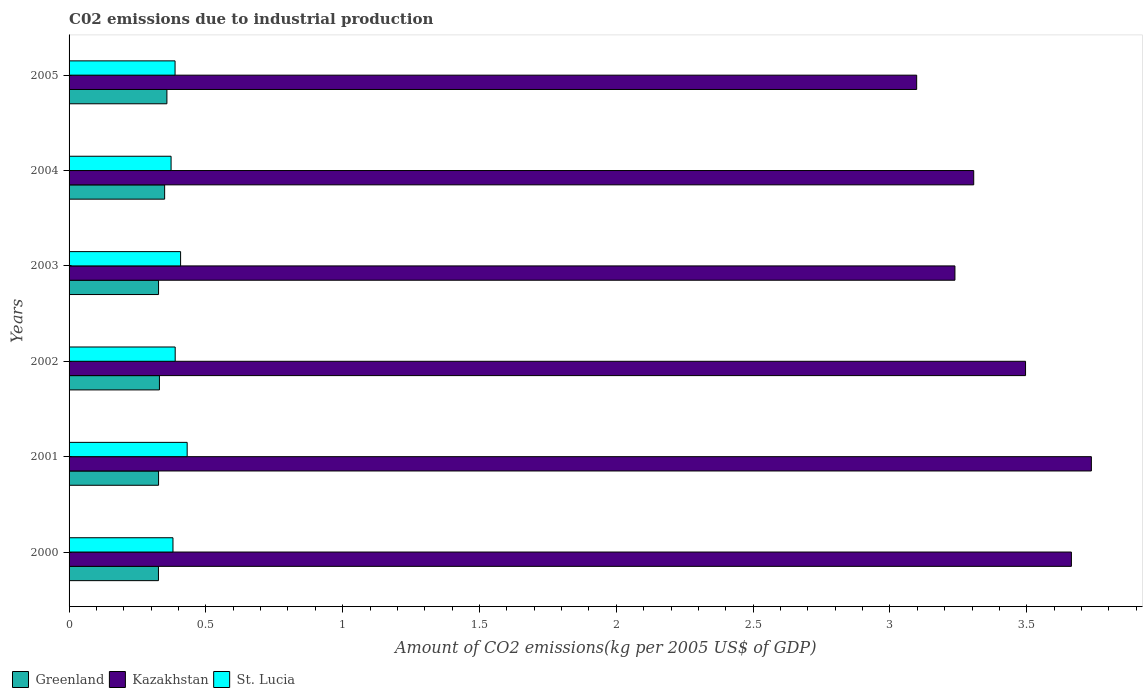Are the number of bars per tick equal to the number of legend labels?
Keep it short and to the point. Yes. Are the number of bars on each tick of the Y-axis equal?
Keep it short and to the point. Yes. How many bars are there on the 2nd tick from the top?
Your answer should be very brief. 3. How many bars are there on the 1st tick from the bottom?
Your response must be concise. 3. In how many cases, is the number of bars for a given year not equal to the number of legend labels?
Give a very brief answer. 0. What is the amount of CO2 emitted due to industrial production in Greenland in 2004?
Give a very brief answer. 0.35. Across all years, what is the maximum amount of CO2 emitted due to industrial production in St. Lucia?
Ensure brevity in your answer.  0.43. Across all years, what is the minimum amount of CO2 emitted due to industrial production in Greenland?
Your answer should be compact. 0.33. In which year was the amount of CO2 emitted due to industrial production in Greenland maximum?
Your answer should be compact. 2005. What is the total amount of CO2 emitted due to industrial production in St. Lucia in the graph?
Keep it short and to the point. 2.37. What is the difference between the amount of CO2 emitted due to industrial production in Greenland in 2003 and that in 2004?
Provide a succinct answer. -0.02. What is the difference between the amount of CO2 emitted due to industrial production in St. Lucia in 2004 and the amount of CO2 emitted due to industrial production in Kazakhstan in 2000?
Ensure brevity in your answer.  -3.29. What is the average amount of CO2 emitted due to industrial production in St. Lucia per year?
Keep it short and to the point. 0.39. In the year 2000, what is the difference between the amount of CO2 emitted due to industrial production in St. Lucia and amount of CO2 emitted due to industrial production in Greenland?
Your response must be concise. 0.05. What is the ratio of the amount of CO2 emitted due to industrial production in St. Lucia in 2001 to that in 2002?
Ensure brevity in your answer.  1.11. Is the amount of CO2 emitted due to industrial production in Kazakhstan in 2000 less than that in 2002?
Offer a terse response. No. Is the difference between the amount of CO2 emitted due to industrial production in St. Lucia in 2003 and 2005 greater than the difference between the amount of CO2 emitted due to industrial production in Greenland in 2003 and 2005?
Keep it short and to the point. Yes. What is the difference between the highest and the second highest amount of CO2 emitted due to industrial production in Kazakhstan?
Offer a very short reply. 0.07. What is the difference between the highest and the lowest amount of CO2 emitted due to industrial production in Greenland?
Your answer should be very brief. 0.03. What does the 3rd bar from the top in 2003 represents?
Your answer should be compact. Greenland. What does the 3rd bar from the bottom in 2003 represents?
Your response must be concise. St. Lucia. Is it the case that in every year, the sum of the amount of CO2 emitted due to industrial production in St. Lucia and amount of CO2 emitted due to industrial production in Greenland is greater than the amount of CO2 emitted due to industrial production in Kazakhstan?
Ensure brevity in your answer.  No. How many bars are there?
Provide a succinct answer. 18. Are all the bars in the graph horizontal?
Your answer should be compact. Yes. Are the values on the major ticks of X-axis written in scientific E-notation?
Make the answer very short. No. Where does the legend appear in the graph?
Offer a very short reply. Bottom left. What is the title of the graph?
Ensure brevity in your answer.  C02 emissions due to industrial production. Does "Swaziland" appear as one of the legend labels in the graph?
Provide a short and direct response. No. What is the label or title of the X-axis?
Your response must be concise. Amount of CO2 emissions(kg per 2005 US$ of GDP). What is the label or title of the Y-axis?
Provide a succinct answer. Years. What is the Amount of CO2 emissions(kg per 2005 US$ of GDP) of Greenland in 2000?
Your response must be concise. 0.33. What is the Amount of CO2 emissions(kg per 2005 US$ of GDP) in Kazakhstan in 2000?
Your answer should be very brief. 3.66. What is the Amount of CO2 emissions(kg per 2005 US$ of GDP) in St. Lucia in 2000?
Offer a very short reply. 0.38. What is the Amount of CO2 emissions(kg per 2005 US$ of GDP) of Greenland in 2001?
Offer a very short reply. 0.33. What is the Amount of CO2 emissions(kg per 2005 US$ of GDP) in Kazakhstan in 2001?
Your response must be concise. 3.74. What is the Amount of CO2 emissions(kg per 2005 US$ of GDP) of St. Lucia in 2001?
Your answer should be very brief. 0.43. What is the Amount of CO2 emissions(kg per 2005 US$ of GDP) of Greenland in 2002?
Give a very brief answer. 0.33. What is the Amount of CO2 emissions(kg per 2005 US$ of GDP) of Kazakhstan in 2002?
Ensure brevity in your answer.  3.5. What is the Amount of CO2 emissions(kg per 2005 US$ of GDP) of St. Lucia in 2002?
Your response must be concise. 0.39. What is the Amount of CO2 emissions(kg per 2005 US$ of GDP) of Greenland in 2003?
Keep it short and to the point. 0.33. What is the Amount of CO2 emissions(kg per 2005 US$ of GDP) of Kazakhstan in 2003?
Provide a succinct answer. 3.24. What is the Amount of CO2 emissions(kg per 2005 US$ of GDP) of St. Lucia in 2003?
Keep it short and to the point. 0.41. What is the Amount of CO2 emissions(kg per 2005 US$ of GDP) in Greenland in 2004?
Provide a short and direct response. 0.35. What is the Amount of CO2 emissions(kg per 2005 US$ of GDP) of Kazakhstan in 2004?
Make the answer very short. 3.31. What is the Amount of CO2 emissions(kg per 2005 US$ of GDP) in St. Lucia in 2004?
Provide a succinct answer. 0.37. What is the Amount of CO2 emissions(kg per 2005 US$ of GDP) in Greenland in 2005?
Keep it short and to the point. 0.36. What is the Amount of CO2 emissions(kg per 2005 US$ of GDP) in Kazakhstan in 2005?
Provide a short and direct response. 3.1. What is the Amount of CO2 emissions(kg per 2005 US$ of GDP) of St. Lucia in 2005?
Your response must be concise. 0.39. Across all years, what is the maximum Amount of CO2 emissions(kg per 2005 US$ of GDP) in Greenland?
Your answer should be compact. 0.36. Across all years, what is the maximum Amount of CO2 emissions(kg per 2005 US$ of GDP) in Kazakhstan?
Offer a very short reply. 3.74. Across all years, what is the maximum Amount of CO2 emissions(kg per 2005 US$ of GDP) in St. Lucia?
Provide a short and direct response. 0.43. Across all years, what is the minimum Amount of CO2 emissions(kg per 2005 US$ of GDP) in Greenland?
Keep it short and to the point. 0.33. Across all years, what is the minimum Amount of CO2 emissions(kg per 2005 US$ of GDP) of Kazakhstan?
Your answer should be compact. 3.1. Across all years, what is the minimum Amount of CO2 emissions(kg per 2005 US$ of GDP) of St. Lucia?
Ensure brevity in your answer.  0.37. What is the total Amount of CO2 emissions(kg per 2005 US$ of GDP) of Greenland in the graph?
Provide a succinct answer. 2.02. What is the total Amount of CO2 emissions(kg per 2005 US$ of GDP) of Kazakhstan in the graph?
Ensure brevity in your answer.  20.54. What is the total Amount of CO2 emissions(kg per 2005 US$ of GDP) in St. Lucia in the graph?
Your response must be concise. 2.37. What is the difference between the Amount of CO2 emissions(kg per 2005 US$ of GDP) in Greenland in 2000 and that in 2001?
Make the answer very short. -0. What is the difference between the Amount of CO2 emissions(kg per 2005 US$ of GDP) of Kazakhstan in 2000 and that in 2001?
Keep it short and to the point. -0.07. What is the difference between the Amount of CO2 emissions(kg per 2005 US$ of GDP) in St. Lucia in 2000 and that in 2001?
Ensure brevity in your answer.  -0.05. What is the difference between the Amount of CO2 emissions(kg per 2005 US$ of GDP) of Greenland in 2000 and that in 2002?
Your answer should be compact. -0. What is the difference between the Amount of CO2 emissions(kg per 2005 US$ of GDP) in Kazakhstan in 2000 and that in 2002?
Provide a succinct answer. 0.17. What is the difference between the Amount of CO2 emissions(kg per 2005 US$ of GDP) of St. Lucia in 2000 and that in 2002?
Give a very brief answer. -0.01. What is the difference between the Amount of CO2 emissions(kg per 2005 US$ of GDP) of Greenland in 2000 and that in 2003?
Offer a terse response. -0. What is the difference between the Amount of CO2 emissions(kg per 2005 US$ of GDP) in Kazakhstan in 2000 and that in 2003?
Give a very brief answer. 0.43. What is the difference between the Amount of CO2 emissions(kg per 2005 US$ of GDP) in St. Lucia in 2000 and that in 2003?
Your answer should be very brief. -0.03. What is the difference between the Amount of CO2 emissions(kg per 2005 US$ of GDP) in Greenland in 2000 and that in 2004?
Make the answer very short. -0.02. What is the difference between the Amount of CO2 emissions(kg per 2005 US$ of GDP) of Kazakhstan in 2000 and that in 2004?
Ensure brevity in your answer.  0.36. What is the difference between the Amount of CO2 emissions(kg per 2005 US$ of GDP) in St. Lucia in 2000 and that in 2004?
Offer a very short reply. 0.01. What is the difference between the Amount of CO2 emissions(kg per 2005 US$ of GDP) of Greenland in 2000 and that in 2005?
Your answer should be very brief. -0.03. What is the difference between the Amount of CO2 emissions(kg per 2005 US$ of GDP) of Kazakhstan in 2000 and that in 2005?
Offer a terse response. 0.57. What is the difference between the Amount of CO2 emissions(kg per 2005 US$ of GDP) in St. Lucia in 2000 and that in 2005?
Your response must be concise. -0.01. What is the difference between the Amount of CO2 emissions(kg per 2005 US$ of GDP) of Greenland in 2001 and that in 2002?
Your answer should be compact. -0. What is the difference between the Amount of CO2 emissions(kg per 2005 US$ of GDP) of Kazakhstan in 2001 and that in 2002?
Give a very brief answer. 0.24. What is the difference between the Amount of CO2 emissions(kg per 2005 US$ of GDP) of St. Lucia in 2001 and that in 2002?
Ensure brevity in your answer.  0.04. What is the difference between the Amount of CO2 emissions(kg per 2005 US$ of GDP) of Greenland in 2001 and that in 2003?
Provide a short and direct response. 0. What is the difference between the Amount of CO2 emissions(kg per 2005 US$ of GDP) in Kazakhstan in 2001 and that in 2003?
Offer a terse response. 0.5. What is the difference between the Amount of CO2 emissions(kg per 2005 US$ of GDP) in St. Lucia in 2001 and that in 2003?
Your response must be concise. 0.02. What is the difference between the Amount of CO2 emissions(kg per 2005 US$ of GDP) of Greenland in 2001 and that in 2004?
Your answer should be compact. -0.02. What is the difference between the Amount of CO2 emissions(kg per 2005 US$ of GDP) of Kazakhstan in 2001 and that in 2004?
Ensure brevity in your answer.  0.43. What is the difference between the Amount of CO2 emissions(kg per 2005 US$ of GDP) in St. Lucia in 2001 and that in 2004?
Provide a succinct answer. 0.06. What is the difference between the Amount of CO2 emissions(kg per 2005 US$ of GDP) of Greenland in 2001 and that in 2005?
Give a very brief answer. -0.03. What is the difference between the Amount of CO2 emissions(kg per 2005 US$ of GDP) in Kazakhstan in 2001 and that in 2005?
Your answer should be very brief. 0.64. What is the difference between the Amount of CO2 emissions(kg per 2005 US$ of GDP) of St. Lucia in 2001 and that in 2005?
Provide a succinct answer. 0.04. What is the difference between the Amount of CO2 emissions(kg per 2005 US$ of GDP) of Greenland in 2002 and that in 2003?
Keep it short and to the point. 0. What is the difference between the Amount of CO2 emissions(kg per 2005 US$ of GDP) in Kazakhstan in 2002 and that in 2003?
Offer a terse response. 0.26. What is the difference between the Amount of CO2 emissions(kg per 2005 US$ of GDP) in St. Lucia in 2002 and that in 2003?
Offer a terse response. -0.02. What is the difference between the Amount of CO2 emissions(kg per 2005 US$ of GDP) in Greenland in 2002 and that in 2004?
Your answer should be compact. -0.02. What is the difference between the Amount of CO2 emissions(kg per 2005 US$ of GDP) of Kazakhstan in 2002 and that in 2004?
Offer a terse response. 0.19. What is the difference between the Amount of CO2 emissions(kg per 2005 US$ of GDP) in St. Lucia in 2002 and that in 2004?
Your answer should be compact. 0.02. What is the difference between the Amount of CO2 emissions(kg per 2005 US$ of GDP) of Greenland in 2002 and that in 2005?
Provide a succinct answer. -0.03. What is the difference between the Amount of CO2 emissions(kg per 2005 US$ of GDP) in Kazakhstan in 2002 and that in 2005?
Give a very brief answer. 0.4. What is the difference between the Amount of CO2 emissions(kg per 2005 US$ of GDP) in St. Lucia in 2002 and that in 2005?
Give a very brief answer. 0. What is the difference between the Amount of CO2 emissions(kg per 2005 US$ of GDP) of Greenland in 2003 and that in 2004?
Ensure brevity in your answer.  -0.02. What is the difference between the Amount of CO2 emissions(kg per 2005 US$ of GDP) of Kazakhstan in 2003 and that in 2004?
Your answer should be compact. -0.07. What is the difference between the Amount of CO2 emissions(kg per 2005 US$ of GDP) in St. Lucia in 2003 and that in 2004?
Provide a succinct answer. 0.03. What is the difference between the Amount of CO2 emissions(kg per 2005 US$ of GDP) in Greenland in 2003 and that in 2005?
Provide a short and direct response. -0.03. What is the difference between the Amount of CO2 emissions(kg per 2005 US$ of GDP) in Kazakhstan in 2003 and that in 2005?
Your answer should be compact. 0.14. What is the difference between the Amount of CO2 emissions(kg per 2005 US$ of GDP) of St. Lucia in 2003 and that in 2005?
Offer a very short reply. 0.02. What is the difference between the Amount of CO2 emissions(kg per 2005 US$ of GDP) in Greenland in 2004 and that in 2005?
Give a very brief answer. -0.01. What is the difference between the Amount of CO2 emissions(kg per 2005 US$ of GDP) of Kazakhstan in 2004 and that in 2005?
Offer a terse response. 0.21. What is the difference between the Amount of CO2 emissions(kg per 2005 US$ of GDP) in St. Lucia in 2004 and that in 2005?
Ensure brevity in your answer.  -0.01. What is the difference between the Amount of CO2 emissions(kg per 2005 US$ of GDP) of Greenland in 2000 and the Amount of CO2 emissions(kg per 2005 US$ of GDP) of Kazakhstan in 2001?
Offer a very short reply. -3.41. What is the difference between the Amount of CO2 emissions(kg per 2005 US$ of GDP) in Greenland in 2000 and the Amount of CO2 emissions(kg per 2005 US$ of GDP) in St. Lucia in 2001?
Keep it short and to the point. -0.1. What is the difference between the Amount of CO2 emissions(kg per 2005 US$ of GDP) of Kazakhstan in 2000 and the Amount of CO2 emissions(kg per 2005 US$ of GDP) of St. Lucia in 2001?
Ensure brevity in your answer.  3.23. What is the difference between the Amount of CO2 emissions(kg per 2005 US$ of GDP) of Greenland in 2000 and the Amount of CO2 emissions(kg per 2005 US$ of GDP) of Kazakhstan in 2002?
Your response must be concise. -3.17. What is the difference between the Amount of CO2 emissions(kg per 2005 US$ of GDP) of Greenland in 2000 and the Amount of CO2 emissions(kg per 2005 US$ of GDP) of St. Lucia in 2002?
Provide a succinct answer. -0.06. What is the difference between the Amount of CO2 emissions(kg per 2005 US$ of GDP) in Kazakhstan in 2000 and the Amount of CO2 emissions(kg per 2005 US$ of GDP) in St. Lucia in 2002?
Offer a very short reply. 3.28. What is the difference between the Amount of CO2 emissions(kg per 2005 US$ of GDP) in Greenland in 2000 and the Amount of CO2 emissions(kg per 2005 US$ of GDP) in Kazakhstan in 2003?
Provide a succinct answer. -2.91. What is the difference between the Amount of CO2 emissions(kg per 2005 US$ of GDP) in Greenland in 2000 and the Amount of CO2 emissions(kg per 2005 US$ of GDP) in St. Lucia in 2003?
Ensure brevity in your answer.  -0.08. What is the difference between the Amount of CO2 emissions(kg per 2005 US$ of GDP) in Kazakhstan in 2000 and the Amount of CO2 emissions(kg per 2005 US$ of GDP) in St. Lucia in 2003?
Make the answer very short. 3.26. What is the difference between the Amount of CO2 emissions(kg per 2005 US$ of GDP) of Greenland in 2000 and the Amount of CO2 emissions(kg per 2005 US$ of GDP) of Kazakhstan in 2004?
Ensure brevity in your answer.  -2.98. What is the difference between the Amount of CO2 emissions(kg per 2005 US$ of GDP) in Greenland in 2000 and the Amount of CO2 emissions(kg per 2005 US$ of GDP) in St. Lucia in 2004?
Ensure brevity in your answer.  -0.05. What is the difference between the Amount of CO2 emissions(kg per 2005 US$ of GDP) in Kazakhstan in 2000 and the Amount of CO2 emissions(kg per 2005 US$ of GDP) in St. Lucia in 2004?
Offer a terse response. 3.29. What is the difference between the Amount of CO2 emissions(kg per 2005 US$ of GDP) in Greenland in 2000 and the Amount of CO2 emissions(kg per 2005 US$ of GDP) in Kazakhstan in 2005?
Keep it short and to the point. -2.77. What is the difference between the Amount of CO2 emissions(kg per 2005 US$ of GDP) in Greenland in 2000 and the Amount of CO2 emissions(kg per 2005 US$ of GDP) in St. Lucia in 2005?
Your answer should be compact. -0.06. What is the difference between the Amount of CO2 emissions(kg per 2005 US$ of GDP) in Kazakhstan in 2000 and the Amount of CO2 emissions(kg per 2005 US$ of GDP) in St. Lucia in 2005?
Keep it short and to the point. 3.28. What is the difference between the Amount of CO2 emissions(kg per 2005 US$ of GDP) in Greenland in 2001 and the Amount of CO2 emissions(kg per 2005 US$ of GDP) in Kazakhstan in 2002?
Your answer should be very brief. -3.17. What is the difference between the Amount of CO2 emissions(kg per 2005 US$ of GDP) in Greenland in 2001 and the Amount of CO2 emissions(kg per 2005 US$ of GDP) in St. Lucia in 2002?
Keep it short and to the point. -0.06. What is the difference between the Amount of CO2 emissions(kg per 2005 US$ of GDP) of Kazakhstan in 2001 and the Amount of CO2 emissions(kg per 2005 US$ of GDP) of St. Lucia in 2002?
Your response must be concise. 3.35. What is the difference between the Amount of CO2 emissions(kg per 2005 US$ of GDP) in Greenland in 2001 and the Amount of CO2 emissions(kg per 2005 US$ of GDP) in Kazakhstan in 2003?
Provide a short and direct response. -2.91. What is the difference between the Amount of CO2 emissions(kg per 2005 US$ of GDP) in Greenland in 2001 and the Amount of CO2 emissions(kg per 2005 US$ of GDP) in St. Lucia in 2003?
Provide a succinct answer. -0.08. What is the difference between the Amount of CO2 emissions(kg per 2005 US$ of GDP) of Kazakhstan in 2001 and the Amount of CO2 emissions(kg per 2005 US$ of GDP) of St. Lucia in 2003?
Make the answer very short. 3.33. What is the difference between the Amount of CO2 emissions(kg per 2005 US$ of GDP) in Greenland in 2001 and the Amount of CO2 emissions(kg per 2005 US$ of GDP) in Kazakhstan in 2004?
Give a very brief answer. -2.98. What is the difference between the Amount of CO2 emissions(kg per 2005 US$ of GDP) in Greenland in 2001 and the Amount of CO2 emissions(kg per 2005 US$ of GDP) in St. Lucia in 2004?
Offer a very short reply. -0.05. What is the difference between the Amount of CO2 emissions(kg per 2005 US$ of GDP) in Kazakhstan in 2001 and the Amount of CO2 emissions(kg per 2005 US$ of GDP) in St. Lucia in 2004?
Your response must be concise. 3.36. What is the difference between the Amount of CO2 emissions(kg per 2005 US$ of GDP) in Greenland in 2001 and the Amount of CO2 emissions(kg per 2005 US$ of GDP) in Kazakhstan in 2005?
Provide a succinct answer. -2.77. What is the difference between the Amount of CO2 emissions(kg per 2005 US$ of GDP) of Greenland in 2001 and the Amount of CO2 emissions(kg per 2005 US$ of GDP) of St. Lucia in 2005?
Offer a terse response. -0.06. What is the difference between the Amount of CO2 emissions(kg per 2005 US$ of GDP) of Kazakhstan in 2001 and the Amount of CO2 emissions(kg per 2005 US$ of GDP) of St. Lucia in 2005?
Provide a short and direct response. 3.35. What is the difference between the Amount of CO2 emissions(kg per 2005 US$ of GDP) in Greenland in 2002 and the Amount of CO2 emissions(kg per 2005 US$ of GDP) in Kazakhstan in 2003?
Keep it short and to the point. -2.91. What is the difference between the Amount of CO2 emissions(kg per 2005 US$ of GDP) of Greenland in 2002 and the Amount of CO2 emissions(kg per 2005 US$ of GDP) of St. Lucia in 2003?
Make the answer very short. -0.08. What is the difference between the Amount of CO2 emissions(kg per 2005 US$ of GDP) in Kazakhstan in 2002 and the Amount of CO2 emissions(kg per 2005 US$ of GDP) in St. Lucia in 2003?
Give a very brief answer. 3.09. What is the difference between the Amount of CO2 emissions(kg per 2005 US$ of GDP) in Greenland in 2002 and the Amount of CO2 emissions(kg per 2005 US$ of GDP) in Kazakhstan in 2004?
Provide a succinct answer. -2.98. What is the difference between the Amount of CO2 emissions(kg per 2005 US$ of GDP) in Greenland in 2002 and the Amount of CO2 emissions(kg per 2005 US$ of GDP) in St. Lucia in 2004?
Your response must be concise. -0.04. What is the difference between the Amount of CO2 emissions(kg per 2005 US$ of GDP) of Kazakhstan in 2002 and the Amount of CO2 emissions(kg per 2005 US$ of GDP) of St. Lucia in 2004?
Your answer should be compact. 3.12. What is the difference between the Amount of CO2 emissions(kg per 2005 US$ of GDP) in Greenland in 2002 and the Amount of CO2 emissions(kg per 2005 US$ of GDP) in Kazakhstan in 2005?
Your answer should be compact. -2.77. What is the difference between the Amount of CO2 emissions(kg per 2005 US$ of GDP) in Greenland in 2002 and the Amount of CO2 emissions(kg per 2005 US$ of GDP) in St. Lucia in 2005?
Offer a very short reply. -0.06. What is the difference between the Amount of CO2 emissions(kg per 2005 US$ of GDP) of Kazakhstan in 2002 and the Amount of CO2 emissions(kg per 2005 US$ of GDP) of St. Lucia in 2005?
Give a very brief answer. 3.11. What is the difference between the Amount of CO2 emissions(kg per 2005 US$ of GDP) of Greenland in 2003 and the Amount of CO2 emissions(kg per 2005 US$ of GDP) of Kazakhstan in 2004?
Offer a very short reply. -2.98. What is the difference between the Amount of CO2 emissions(kg per 2005 US$ of GDP) in Greenland in 2003 and the Amount of CO2 emissions(kg per 2005 US$ of GDP) in St. Lucia in 2004?
Provide a succinct answer. -0.05. What is the difference between the Amount of CO2 emissions(kg per 2005 US$ of GDP) of Kazakhstan in 2003 and the Amount of CO2 emissions(kg per 2005 US$ of GDP) of St. Lucia in 2004?
Make the answer very short. 2.86. What is the difference between the Amount of CO2 emissions(kg per 2005 US$ of GDP) in Greenland in 2003 and the Amount of CO2 emissions(kg per 2005 US$ of GDP) in Kazakhstan in 2005?
Provide a short and direct response. -2.77. What is the difference between the Amount of CO2 emissions(kg per 2005 US$ of GDP) of Greenland in 2003 and the Amount of CO2 emissions(kg per 2005 US$ of GDP) of St. Lucia in 2005?
Give a very brief answer. -0.06. What is the difference between the Amount of CO2 emissions(kg per 2005 US$ of GDP) of Kazakhstan in 2003 and the Amount of CO2 emissions(kg per 2005 US$ of GDP) of St. Lucia in 2005?
Offer a very short reply. 2.85. What is the difference between the Amount of CO2 emissions(kg per 2005 US$ of GDP) of Greenland in 2004 and the Amount of CO2 emissions(kg per 2005 US$ of GDP) of Kazakhstan in 2005?
Make the answer very short. -2.75. What is the difference between the Amount of CO2 emissions(kg per 2005 US$ of GDP) of Greenland in 2004 and the Amount of CO2 emissions(kg per 2005 US$ of GDP) of St. Lucia in 2005?
Your response must be concise. -0.04. What is the difference between the Amount of CO2 emissions(kg per 2005 US$ of GDP) in Kazakhstan in 2004 and the Amount of CO2 emissions(kg per 2005 US$ of GDP) in St. Lucia in 2005?
Offer a very short reply. 2.92. What is the average Amount of CO2 emissions(kg per 2005 US$ of GDP) in Greenland per year?
Provide a short and direct response. 0.34. What is the average Amount of CO2 emissions(kg per 2005 US$ of GDP) in Kazakhstan per year?
Ensure brevity in your answer.  3.42. What is the average Amount of CO2 emissions(kg per 2005 US$ of GDP) of St. Lucia per year?
Make the answer very short. 0.39. In the year 2000, what is the difference between the Amount of CO2 emissions(kg per 2005 US$ of GDP) of Greenland and Amount of CO2 emissions(kg per 2005 US$ of GDP) of Kazakhstan?
Provide a succinct answer. -3.34. In the year 2000, what is the difference between the Amount of CO2 emissions(kg per 2005 US$ of GDP) of Greenland and Amount of CO2 emissions(kg per 2005 US$ of GDP) of St. Lucia?
Give a very brief answer. -0.05. In the year 2000, what is the difference between the Amount of CO2 emissions(kg per 2005 US$ of GDP) of Kazakhstan and Amount of CO2 emissions(kg per 2005 US$ of GDP) of St. Lucia?
Keep it short and to the point. 3.28. In the year 2001, what is the difference between the Amount of CO2 emissions(kg per 2005 US$ of GDP) of Greenland and Amount of CO2 emissions(kg per 2005 US$ of GDP) of Kazakhstan?
Offer a terse response. -3.41. In the year 2001, what is the difference between the Amount of CO2 emissions(kg per 2005 US$ of GDP) in Greenland and Amount of CO2 emissions(kg per 2005 US$ of GDP) in St. Lucia?
Ensure brevity in your answer.  -0.1. In the year 2001, what is the difference between the Amount of CO2 emissions(kg per 2005 US$ of GDP) in Kazakhstan and Amount of CO2 emissions(kg per 2005 US$ of GDP) in St. Lucia?
Make the answer very short. 3.3. In the year 2002, what is the difference between the Amount of CO2 emissions(kg per 2005 US$ of GDP) in Greenland and Amount of CO2 emissions(kg per 2005 US$ of GDP) in Kazakhstan?
Provide a short and direct response. -3.17. In the year 2002, what is the difference between the Amount of CO2 emissions(kg per 2005 US$ of GDP) in Greenland and Amount of CO2 emissions(kg per 2005 US$ of GDP) in St. Lucia?
Your answer should be very brief. -0.06. In the year 2002, what is the difference between the Amount of CO2 emissions(kg per 2005 US$ of GDP) of Kazakhstan and Amount of CO2 emissions(kg per 2005 US$ of GDP) of St. Lucia?
Your answer should be very brief. 3.11. In the year 2003, what is the difference between the Amount of CO2 emissions(kg per 2005 US$ of GDP) of Greenland and Amount of CO2 emissions(kg per 2005 US$ of GDP) of Kazakhstan?
Ensure brevity in your answer.  -2.91. In the year 2003, what is the difference between the Amount of CO2 emissions(kg per 2005 US$ of GDP) of Greenland and Amount of CO2 emissions(kg per 2005 US$ of GDP) of St. Lucia?
Give a very brief answer. -0.08. In the year 2003, what is the difference between the Amount of CO2 emissions(kg per 2005 US$ of GDP) in Kazakhstan and Amount of CO2 emissions(kg per 2005 US$ of GDP) in St. Lucia?
Offer a terse response. 2.83. In the year 2004, what is the difference between the Amount of CO2 emissions(kg per 2005 US$ of GDP) of Greenland and Amount of CO2 emissions(kg per 2005 US$ of GDP) of Kazakhstan?
Offer a terse response. -2.96. In the year 2004, what is the difference between the Amount of CO2 emissions(kg per 2005 US$ of GDP) of Greenland and Amount of CO2 emissions(kg per 2005 US$ of GDP) of St. Lucia?
Your response must be concise. -0.02. In the year 2004, what is the difference between the Amount of CO2 emissions(kg per 2005 US$ of GDP) in Kazakhstan and Amount of CO2 emissions(kg per 2005 US$ of GDP) in St. Lucia?
Give a very brief answer. 2.93. In the year 2005, what is the difference between the Amount of CO2 emissions(kg per 2005 US$ of GDP) in Greenland and Amount of CO2 emissions(kg per 2005 US$ of GDP) in Kazakhstan?
Provide a short and direct response. -2.74. In the year 2005, what is the difference between the Amount of CO2 emissions(kg per 2005 US$ of GDP) in Greenland and Amount of CO2 emissions(kg per 2005 US$ of GDP) in St. Lucia?
Provide a succinct answer. -0.03. In the year 2005, what is the difference between the Amount of CO2 emissions(kg per 2005 US$ of GDP) of Kazakhstan and Amount of CO2 emissions(kg per 2005 US$ of GDP) of St. Lucia?
Ensure brevity in your answer.  2.71. What is the ratio of the Amount of CO2 emissions(kg per 2005 US$ of GDP) of Kazakhstan in 2000 to that in 2001?
Offer a terse response. 0.98. What is the ratio of the Amount of CO2 emissions(kg per 2005 US$ of GDP) of St. Lucia in 2000 to that in 2001?
Offer a terse response. 0.88. What is the ratio of the Amount of CO2 emissions(kg per 2005 US$ of GDP) of Kazakhstan in 2000 to that in 2002?
Your answer should be very brief. 1.05. What is the ratio of the Amount of CO2 emissions(kg per 2005 US$ of GDP) in St. Lucia in 2000 to that in 2002?
Your answer should be compact. 0.98. What is the ratio of the Amount of CO2 emissions(kg per 2005 US$ of GDP) in Kazakhstan in 2000 to that in 2003?
Your answer should be very brief. 1.13. What is the ratio of the Amount of CO2 emissions(kg per 2005 US$ of GDP) in St. Lucia in 2000 to that in 2003?
Your answer should be compact. 0.93. What is the ratio of the Amount of CO2 emissions(kg per 2005 US$ of GDP) of Greenland in 2000 to that in 2004?
Provide a succinct answer. 0.94. What is the ratio of the Amount of CO2 emissions(kg per 2005 US$ of GDP) in Kazakhstan in 2000 to that in 2004?
Offer a very short reply. 1.11. What is the ratio of the Amount of CO2 emissions(kg per 2005 US$ of GDP) of St. Lucia in 2000 to that in 2004?
Make the answer very short. 1.02. What is the ratio of the Amount of CO2 emissions(kg per 2005 US$ of GDP) in Greenland in 2000 to that in 2005?
Ensure brevity in your answer.  0.91. What is the ratio of the Amount of CO2 emissions(kg per 2005 US$ of GDP) in Kazakhstan in 2000 to that in 2005?
Provide a short and direct response. 1.18. What is the ratio of the Amount of CO2 emissions(kg per 2005 US$ of GDP) in St. Lucia in 2000 to that in 2005?
Make the answer very short. 0.98. What is the ratio of the Amount of CO2 emissions(kg per 2005 US$ of GDP) in Greenland in 2001 to that in 2002?
Ensure brevity in your answer.  0.99. What is the ratio of the Amount of CO2 emissions(kg per 2005 US$ of GDP) in Kazakhstan in 2001 to that in 2002?
Make the answer very short. 1.07. What is the ratio of the Amount of CO2 emissions(kg per 2005 US$ of GDP) of St. Lucia in 2001 to that in 2002?
Make the answer very short. 1.11. What is the ratio of the Amount of CO2 emissions(kg per 2005 US$ of GDP) of Greenland in 2001 to that in 2003?
Offer a terse response. 1. What is the ratio of the Amount of CO2 emissions(kg per 2005 US$ of GDP) in Kazakhstan in 2001 to that in 2003?
Ensure brevity in your answer.  1.15. What is the ratio of the Amount of CO2 emissions(kg per 2005 US$ of GDP) of St. Lucia in 2001 to that in 2003?
Give a very brief answer. 1.06. What is the ratio of the Amount of CO2 emissions(kg per 2005 US$ of GDP) of Greenland in 2001 to that in 2004?
Keep it short and to the point. 0.94. What is the ratio of the Amount of CO2 emissions(kg per 2005 US$ of GDP) of Kazakhstan in 2001 to that in 2004?
Offer a very short reply. 1.13. What is the ratio of the Amount of CO2 emissions(kg per 2005 US$ of GDP) in St. Lucia in 2001 to that in 2004?
Give a very brief answer. 1.16. What is the ratio of the Amount of CO2 emissions(kg per 2005 US$ of GDP) in Greenland in 2001 to that in 2005?
Offer a very short reply. 0.91. What is the ratio of the Amount of CO2 emissions(kg per 2005 US$ of GDP) of Kazakhstan in 2001 to that in 2005?
Provide a short and direct response. 1.21. What is the ratio of the Amount of CO2 emissions(kg per 2005 US$ of GDP) in St. Lucia in 2001 to that in 2005?
Offer a terse response. 1.11. What is the ratio of the Amount of CO2 emissions(kg per 2005 US$ of GDP) of Greenland in 2002 to that in 2003?
Provide a succinct answer. 1.01. What is the ratio of the Amount of CO2 emissions(kg per 2005 US$ of GDP) of Kazakhstan in 2002 to that in 2003?
Offer a terse response. 1.08. What is the ratio of the Amount of CO2 emissions(kg per 2005 US$ of GDP) of St. Lucia in 2002 to that in 2003?
Give a very brief answer. 0.95. What is the ratio of the Amount of CO2 emissions(kg per 2005 US$ of GDP) of Greenland in 2002 to that in 2004?
Keep it short and to the point. 0.95. What is the ratio of the Amount of CO2 emissions(kg per 2005 US$ of GDP) in Kazakhstan in 2002 to that in 2004?
Give a very brief answer. 1.06. What is the ratio of the Amount of CO2 emissions(kg per 2005 US$ of GDP) of St. Lucia in 2002 to that in 2004?
Provide a short and direct response. 1.04. What is the ratio of the Amount of CO2 emissions(kg per 2005 US$ of GDP) in Greenland in 2002 to that in 2005?
Ensure brevity in your answer.  0.92. What is the ratio of the Amount of CO2 emissions(kg per 2005 US$ of GDP) of Kazakhstan in 2002 to that in 2005?
Provide a short and direct response. 1.13. What is the ratio of the Amount of CO2 emissions(kg per 2005 US$ of GDP) in Greenland in 2003 to that in 2004?
Your answer should be compact. 0.94. What is the ratio of the Amount of CO2 emissions(kg per 2005 US$ of GDP) of Kazakhstan in 2003 to that in 2004?
Offer a terse response. 0.98. What is the ratio of the Amount of CO2 emissions(kg per 2005 US$ of GDP) in St. Lucia in 2003 to that in 2004?
Provide a short and direct response. 1.09. What is the ratio of the Amount of CO2 emissions(kg per 2005 US$ of GDP) in Greenland in 2003 to that in 2005?
Provide a short and direct response. 0.91. What is the ratio of the Amount of CO2 emissions(kg per 2005 US$ of GDP) in Kazakhstan in 2003 to that in 2005?
Offer a terse response. 1.05. What is the ratio of the Amount of CO2 emissions(kg per 2005 US$ of GDP) in St. Lucia in 2003 to that in 2005?
Provide a short and direct response. 1.05. What is the ratio of the Amount of CO2 emissions(kg per 2005 US$ of GDP) of Greenland in 2004 to that in 2005?
Ensure brevity in your answer.  0.98. What is the ratio of the Amount of CO2 emissions(kg per 2005 US$ of GDP) in Kazakhstan in 2004 to that in 2005?
Ensure brevity in your answer.  1.07. What is the ratio of the Amount of CO2 emissions(kg per 2005 US$ of GDP) of St. Lucia in 2004 to that in 2005?
Your answer should be compact. 0.96. What is the difference between the highest and the second highest Amount of CO2 emissions(kg per 2005 US$ of GDP) of Greenland?
Keep it short and to the point. 0.01. What is the difference between the highest and the second highest Amount of CO2 emissions(kg per 2005 US$ of GDP) of Kazakhstan?
Make the answer very short. 0.07. What is the difference between the highest and the second highest Amount of CO2 emissions(kg per 2005 US$ of GDP) in St. Lucia?
Keep it short and to the point. 0.02. What is the difference between the highest and the lowest Amount of CO2 emissions(kg per 2005 US$ of GDP) of Greenland?
Provide a succinct answer. 0.03. What is the difference between the highest and the lowest Amount of CO2 emissions(kg per 2005 US$ of GDP) of Kazakhstan?
Make the answer very short. 0.64. What is the difference between the highest and the lowest Amount of CO2 emissions(kg per 2005 US$ of GDP) in St. Lucia?
Offer a very short reply. 0.06. 